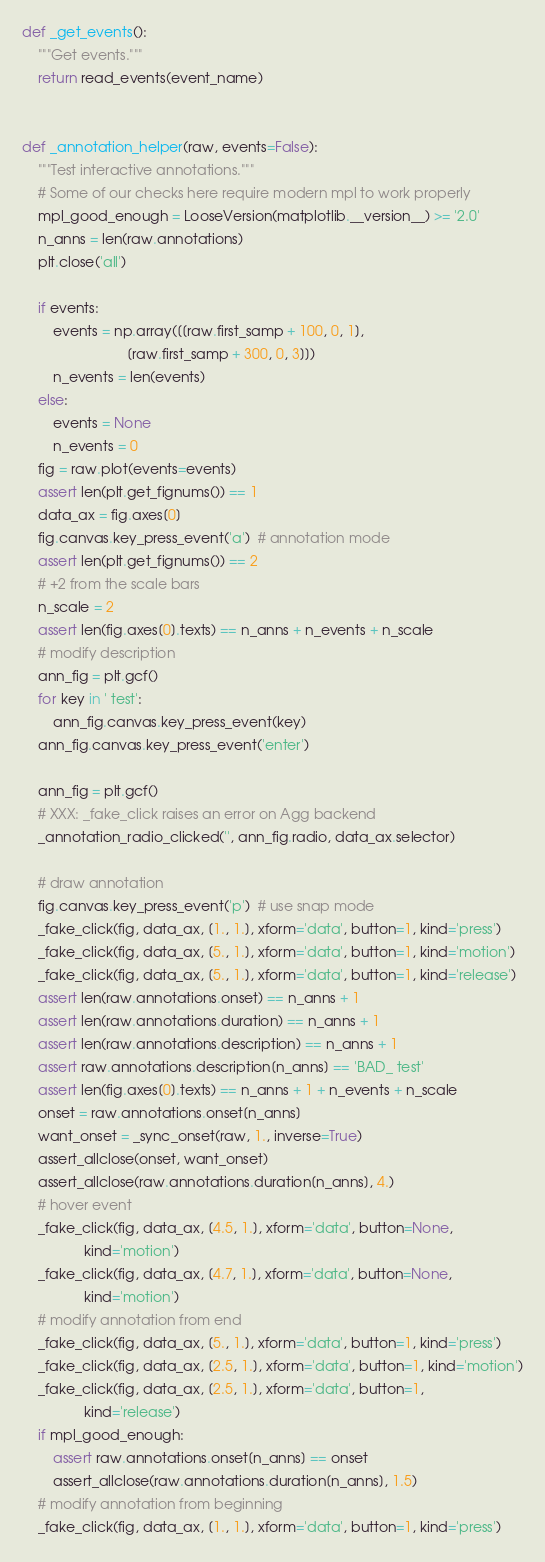<code> <loc_0><loc_0><loc_500><loc_500><_Python_>

def _get_events():
    """Get events."""
    return read_events(event_name)


def _annotation_helper(raw, events=False):
    """Test interactive annotations."""
    # Some of our checks here require modern mpl to work properly
    mpl_good_enough = LooseVersion(matplotlib.__version__) >= '2.0'
    n_anns = len(raw.annotations)
    plt.close('all')

    if events:
        events = np.array([[raw.first_samp + 100, 0, 1],
                           [raw.first_samp + 300, 0, 3]])
        n_events = len(events)
    else:
        events = None
        n_events = 0
    fig = raw.plot(events=events)
    assert len(plt.get_fignums()) == 1
    data_ax = fig.axes[0]
    fig.canvas.key_press_event('a')  # annotation mode
    assert len(plt.get_fignums()) == 2
    # +2 from the scale bars
    n_scale = 2
    assert len(fig.axes[0].texts) == n_anns + n_events + n_scale
    # modify description
    ann_fig = plt.gcf()
    for key in ' test':
        ann_fig.canvas.key_press_event(key)
    ann_fig.canvas.key_press_event('enter')

    ann_fig = plt.gcf()
    # XXX: _fake_click raises an error on Agg backend
    _annotation_radio_clicked('', ann_fig.radio, data_ax.selector)

    # draw annotation
    fig.canvas.key_press_event('p')  # use snap mode
    _fake_click(fig, data_ax, [1., 1.], xform='data', button=1, kind='press')
    _fake_click(fig, data_ax, [5., 1.], xform='data', button=1, kind='motion')
    _fake_click(fig, data_ax, [5., 1.], xform='data', button=1, kind='release')
    assert len(raw.annotations.onset) == n_anns + 1
    assert len(raw.annotations.duration) == n_anns + 1
    assert len(raw.annotations.description) == n_anns + 1
    assert raw.annotations.description[n_anns] == 'BAD_ test'
    assert len(fig.axes[0].texts) == n_anns + 1 + n_events + n_scale
    onset = raw.annotations.onset[n_anns]
    want_onset = _sync_onset(raw, 1., inverse=True)
    assert_allclose(onset, want_onset)
    assert_allclose(raw.annotations.duration[n_anns], 4.)
    # hover event
    _fake_click(fig, data_ax, [4.5, 1.], xform='data', button=None,
                kind='motion')
    _fake_click(fig, data_ax, [4.7, 1.], xform='data', button=None,
                kind='motion')
    # modify annotation from end
    _fake_click(fig, data_ax, [5., 1.], xform='data', button=1, kind='press')
    _fake_click(fig, data_ax, [2.5, 1.], xform='data', button=1, kind='motion')
    _fake_click(fig, data_ax, [2.5, 1.], xform='data', button=1,
                kind='release')
    if mpl_good_enough:
        assert raw.annotations.onset[n_anns] == onset
        assert_allclose(raw.annotations.duration[n_anns], 1.5)
    # modify annotation from beginning
    _fake_click(fig, data_ax, [1., 1.], xform='data', button=1, kind='press')</code> 